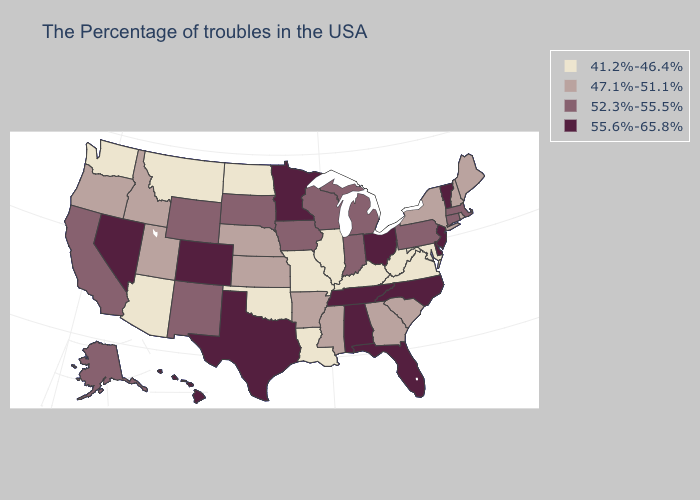What is the highest value in the Northeast ?
Be succinct. 55.6%-65.8%. Name the states that have a value in the range 41.2%-46.4%?
Short answer required. Maryland, Virginia, West Virginia, Kentucky, Illinois, Louisiana, Missouri, Oklahoma, North Dakota, Montana, Arizona, Washington. Name the states that have a value in the range 52.3%-55.5%?
Be succinct. Massachusetts, Connecticut, Pennsylvania, Michigan, Indiana, Wisconsin, Iowa, South Dakota, Wyoming, New Mexico, California, Alaska. Among the states that border New York , which have the lowest value?
Keep it brief. Massachusetts, Connecticut, Pennsylvania. Which states have the lowest value in the West?
Quick response, please. Montana, Arizona, Washington. Name the states that have a value in the range 55.6%-65.8%?
Keep it brief. Vermont, New Jersey, Delaware, North Carolina, Ohio, Florida, Alabama, Tennessee, Minnesota, Texas, Colorado, Nevada, Hawaii. What is the value of Washington?
Quick response, please. 41.2%-46.4%. Among the states that border Wyoming , does Montana have the lowest value?
Concise answer only. Yes. What is the highest value in the MidWest ?
Quick response, please. 55.6%-65.8%. Name the states that have a value in the range 55.6%-65.8%?
Keep it brief. Vermont, New Jersey, Delaware, North Carolina, Ohio, Florida, Alabama, Tennessee, Minnesota, Texas, Colorado, Nevada, Hawaii. What is the highest value in the West ?
Answer briefly. 55.6%-65.8%. Is the legend a continuous bar?
Keep it brief. No. Name the states that have a value in the range 47.1%-51.1%?
Write a very short answer. Maine, Rhode Island, New Hampshire, New York, South Carolina, Georgia, Mississippi, Arkansas, Kansas, Nebraska, Utah, Idaho, Oregon. What is the lowest value in the South?
Short answer required. 41.2%-46.4%. What is the lowest value in the USA?
Write a very short answer. 41.2%-46.4%. 